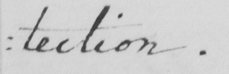What text is written in this handwritten line? : tection . 